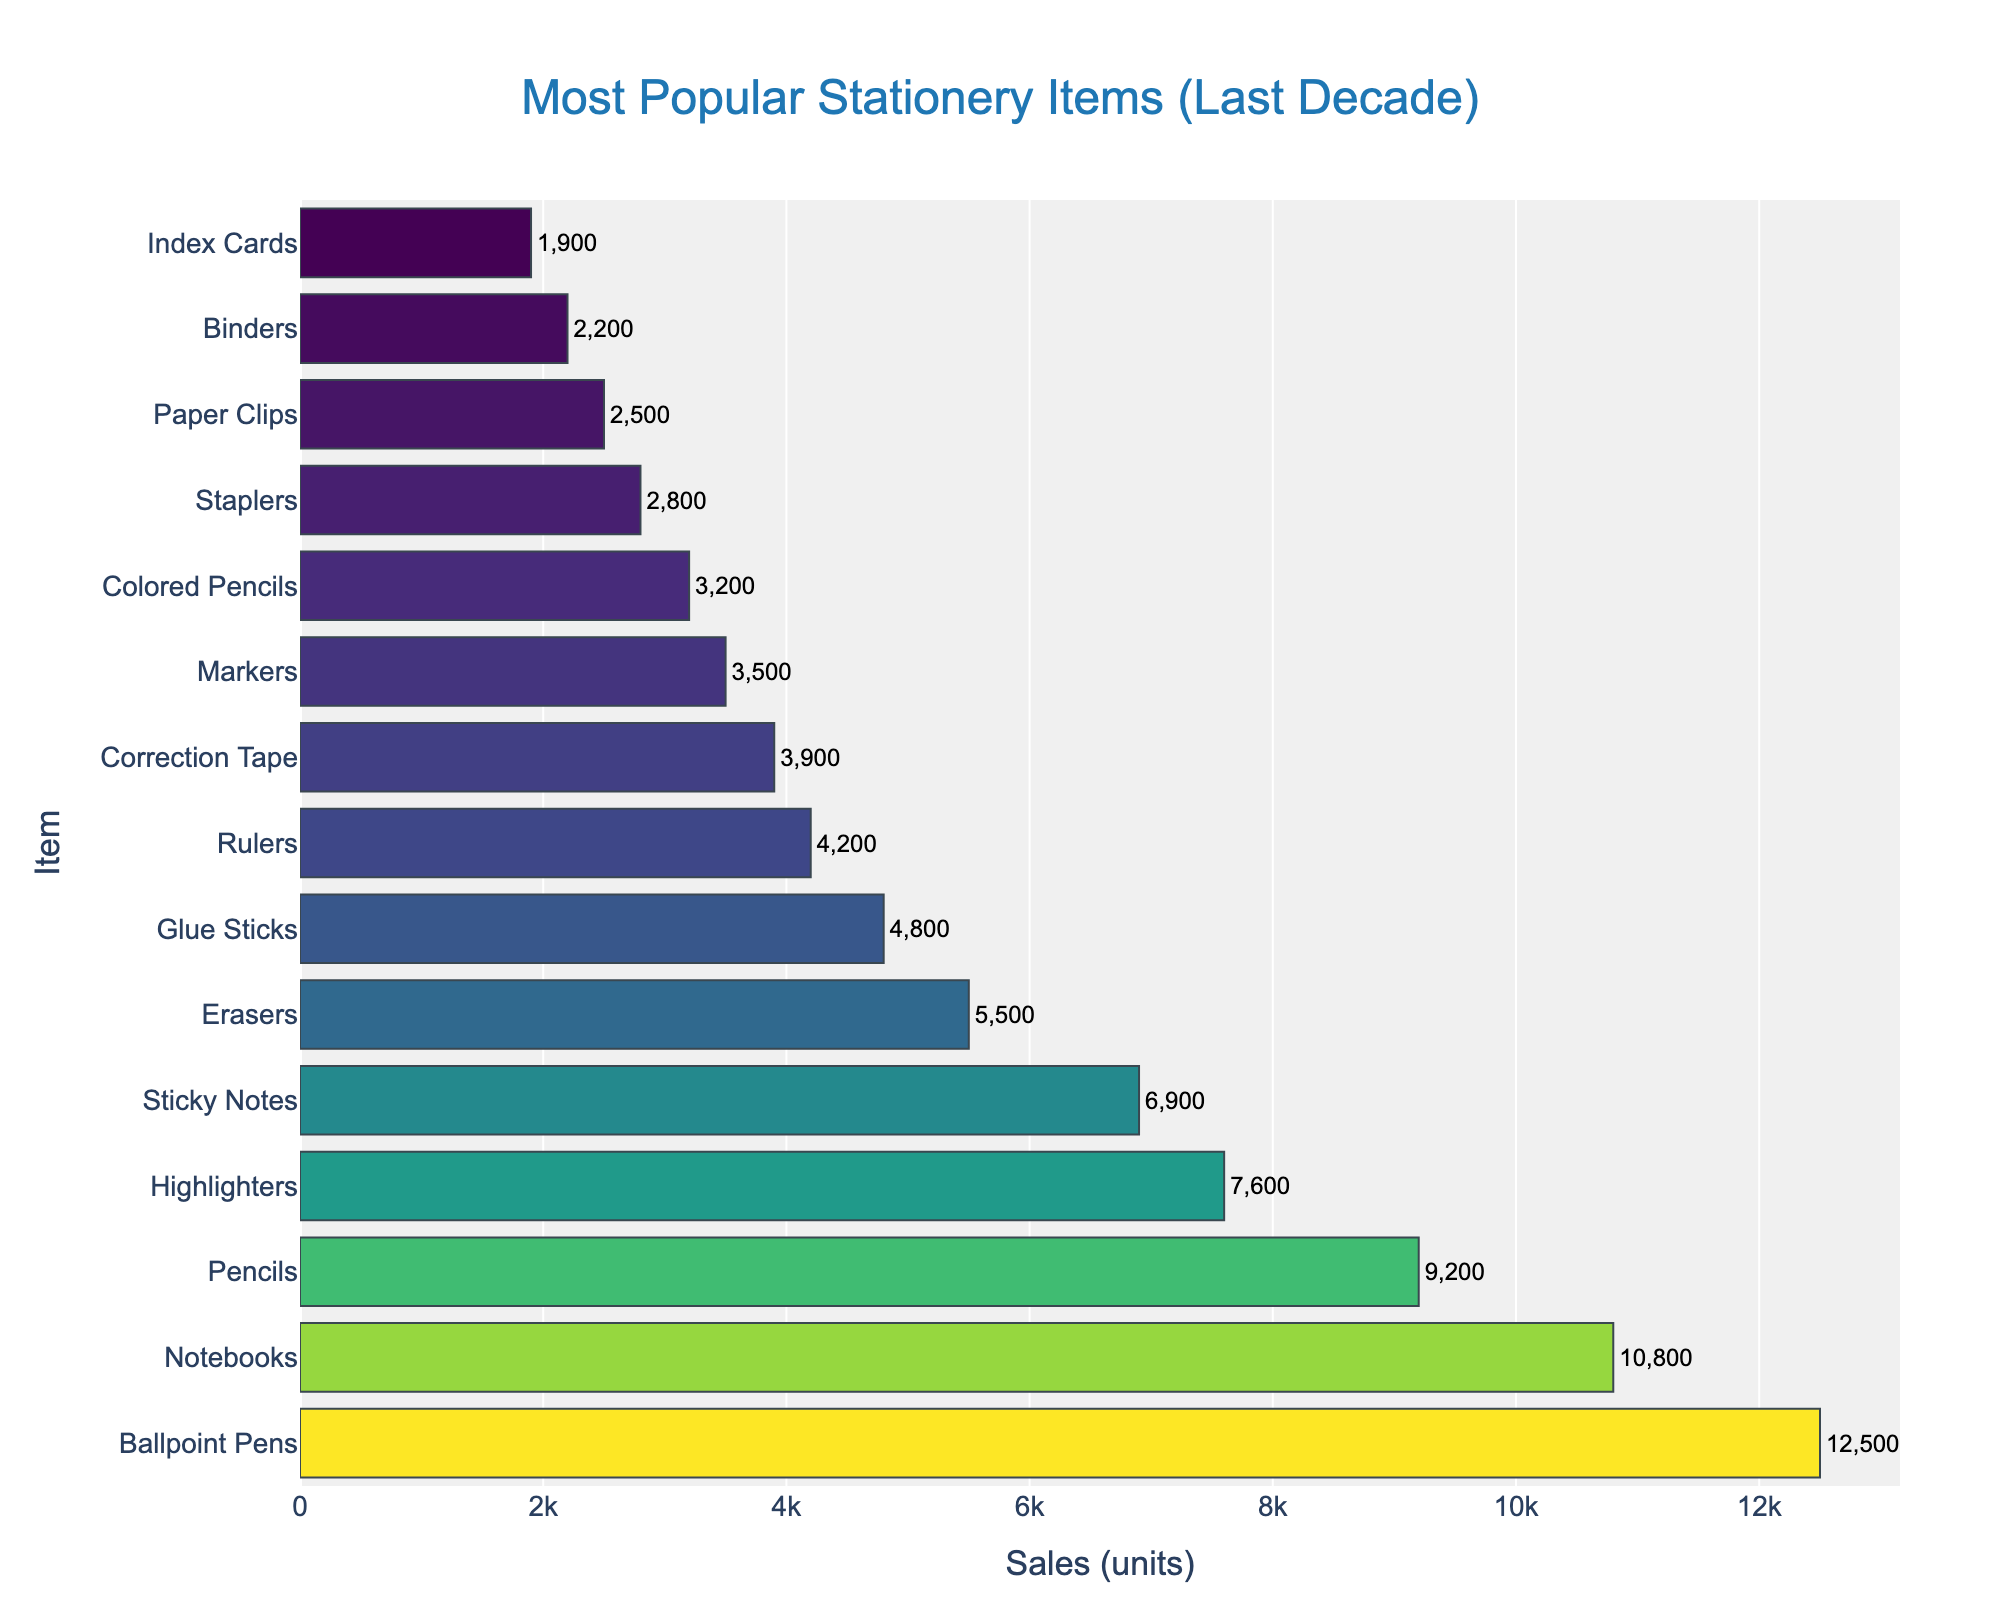What is the total number of sales for Ballpoint Pens and Notebooks combined? First, find the sales values for Ballpoint Pens (12,500) and Notebooks (10,800). Then, add these numbers together: 12,500 + 10,800 = 23,300.
Answer: 23,300 Which item has higher sales, Highlighters or Sticky Notes? Compare the sales units of Highlighters (7,600) and Sticky Notes (6,900). Highlighters have higher sales.
Answer: Highlighters How many more units of Ballpoint Pens were sold compared to Pencils? Find the sales values for Ballpoint Pens (12,500) and Pencils (9,200). Subtract the sales of Pencils from Ballpoint Pens: 12,500 - 9,200 = 3,300.
Answer: 3,300 Which item is sold the least? Identify the items with the lowest bar in the figure. Index Cards have the lowest sales value of 1,900 units.
Answer: Index Cards What is the difference in sales between Erasers and Glue Sticks? Find the sales values for Erasers (5,500) and Glue Sticks (4,800). Subtract the sales of Glue Sticks from Erasers: 5,500 - 4,800 = 700.
Answer: 700 What is the average number of units sold for the top three items? The top three items by sales are Ballpoint Pens (12,500), Notebooks (10,800), and Pencils (9,200). Sum these values: 12,500 + 10,800 + 9,200 = 32,500. Divide by 3 to get the average: 32,500 / 3 ≈ 10,833.
Answer: 10,833 Which item has a darker color on the bar chart, Glue Sticks or Correction Tape? The coloring of the bars depends on the sales units, with higher sales generally resulting in a darker color. Glue Sticks (4,800) have higher sales than Correction Tape (3,900), hence Glue Sticks should appear darker.
Answer: Glue Sticks Is the color of the bar for Markers lighter or darker compared to Colored Pencils? Based on sales, Markers (3,500) have higher sales than Colored Pencils (3,200), suggesting Markers should have a darker color.
Answer: Darker 